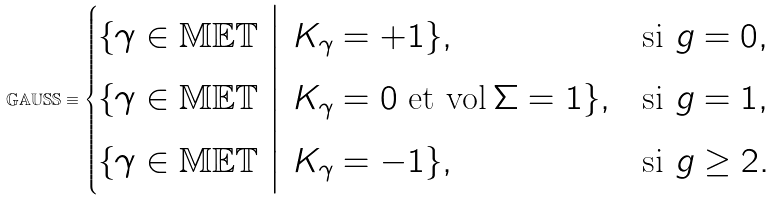Convert formula to latex. <formula><loc_0><loc_0><loc_500><loc_500>\mathbb { G A U S S } \equiv \begin{cases} \{ \gamma \in \mathbb { M E T } \ \Big | \ K _ { \gamma } = + 1 \} , & \text {si $g=0$} , \\ \{ \gamma \in \mathbb { M E T } \ \Big | \ K _ { \gamma } = 0 \ \text {et} \ \text {vol} \, \Sigma = 1 \} , & \text {si $g=1$} , \\ \{ \gamma \in \mathbb { M E T } \ \Big | \ K _ { \gamma } = - 1 \} , & \text {si $g\geq 2$} . \end{cases}</formula> 